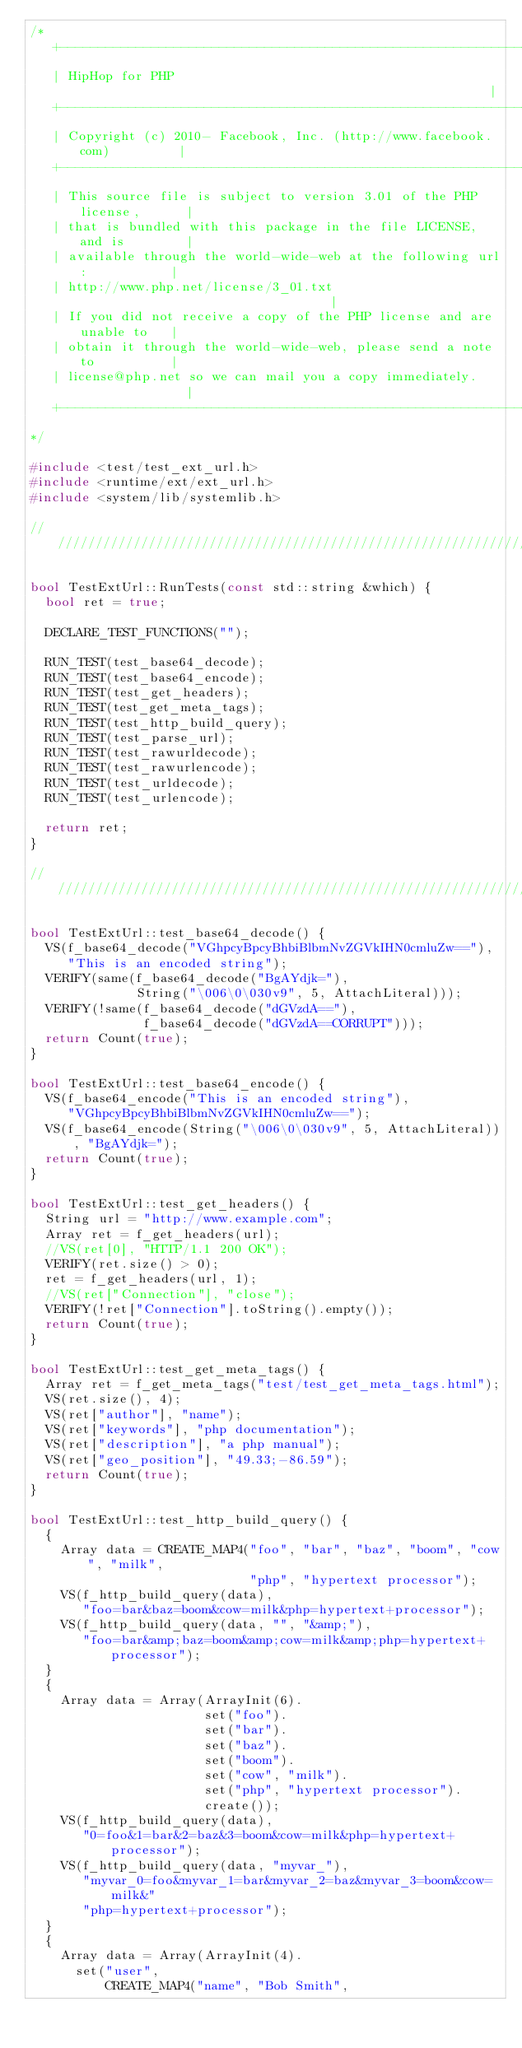<code> <loc_0><loc_0><loc_500><loc_500><_C++_>/*
   +----------------------------------------------------------------------+
   | HipHop for PHP                                                       |
   +----------------------------------------------------------------------+
   | Copyright (c) 2010- Facebook, Inc. (http://www.facebook.com)         |
   +----------------------------------------------------------------------+
   | This source file is subject to version 3.01 of the PHP license,      |
   | that is bundled with this package in the file LICENSE, and is        |
   | available through the world-wide-web at the following url:           |
   | http://www.php.net/license/3_01.txt                                  |
   | If you did not receive a copy of the PHP license and are unable to   |
   | obtain it through the world-wide-web, please send a note to          |
   | license@php.net so we can mail you a copy immediately.               |
   +----------------------------------------------------------------------+
*/

#include <test/test_ext_url.h>
#include <runtime/ext/ext_url.h>
#include <system/lib/systemlib.h>

///////////////////////////////////////////////////////////////////////////////

bool TestExtUrl::RunTests(const std::string &which) {
  bool ret = true;

  DECLARE_TEST_FUNCTIONS("");

  RUN_TEST(test_base64_decode);
  RUN_TEST(test_base64_encode);
  RUN_TEST(test_get_headers);
  RUN_TEST(test_get_meta_tags);
  RUN_TEST(test_http_build_query);
  RUN_TEST(test_parse_url);
  RUN_TEST(test_rawurldecode);
  RUN_TEST(test_rawurlencode);
  RUN_TEST(test_urldecode);
  RUN_TEST(test_urlencode);

  return ret;
}

///////////////////////////////////////////////////////////////////////////////

bool TestExtUrl::test_base64_decode() {
  VS(f_base64_decode("VGhpcyBpcyBhbiBlbmNvZGVkIHN0cmluZw=="),
     "This is an encoded string");
  VERIFY(same(f_base64_decode("BgAYdjk="),
              String("\006\0\030v9", 5, AttachLiteral)));
  VERIFY(!same(f_base64_decode("dGVzdA=="),
               f_base64_decode("dGVzdA==CORRUPT")));
  return Count(true);
}

bool TestExtUrl::test_base64_encode() {
  VS(f_base64_encode("This is an encoded string"),
     "VGhpcyBpcyBhbiBlbmNvZGVkIHN0cmluZw==");
  VS(f_base64_encode(String("\006\0\030v9", 5, AttachLiteral)), "BgAYdjk=");
  return Count(true);
}

bool TestExtUrl::test_get_headers() {
  String url = "http://www.example.com";
  Array ret = f_get_headers(url);
  //VS(ret[0], "HTTP/1.1 200 OK");
  VERIFY(ret.size() > 0);
  ret = f_get_headers(url, 1);
  //VS(ret["Connection"], "close");
  VERIFY(!ret["Connection"].toString().empty());
  return Count(true);
}

bool TestExtUrl::test_get_meta_tags() {
  Array ret = f_get_meta_tags("test/test_get_meta_tags.html");
  VS(ret.size(), 4);
  VS(ret["author"], "name");
  VS(ret["keywords"], "php documentation");
  VS(ret["description"], "a php manual");
  VS(ret["geo_position"], "49.33;-86.59");
  return Count(true);
}

bool TestExtUrl::test_http_build_query() {
  {
    Array data = CREATE_MAP4("foo", "bar", "baz", "boom", "cow", "milk",
                             "php", "hypertext processor");
    VS(f_http_build_query(data),
       "foo=bar&baz=boom&cow=milk&php=hypertext+processor");
    VS(f_http_build_query(data, "", "&amp;"),
       "foo=bar&amp;baz=boom&amp;cow=milk&amp;php=hypertext+processor");
  }
  {
    Array data = Array(ArrayInit(6).
                       set("foo").
                       set("bar").
                       set("baz").
                       set("boom").
                       set("cow", "milk").
                       set("php", "hypertext processor").
                       create());
    VS(f_http_build_query(data),
       "0=foo&1=bar&2=baz&3=boom&cow=milk&php=hypertext+processor");
    VS(f_http_build_query(data, "myvar_"),
       "myvar_0=foo&myvar_1=bar&myvar_2=baz&myvar_3=boom&cow=milk&"
       "php=hypertext+processor");
  }
  {
    Array data = Array(ArrayInit(4).
      set("user",
          CREATE_MAP4("name", "Bob Smith",</code> 